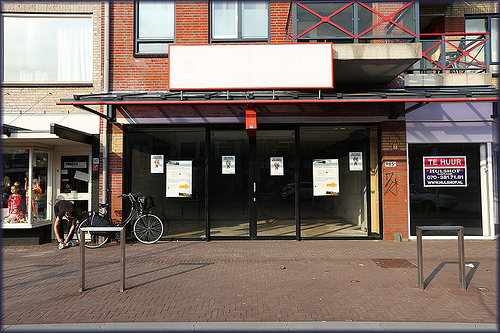<image>
Can you confirm if the man is on the bike? No. The man is not positioned on the bike. They may be near each other, but the man is not supported by or resting on top of the bike. 